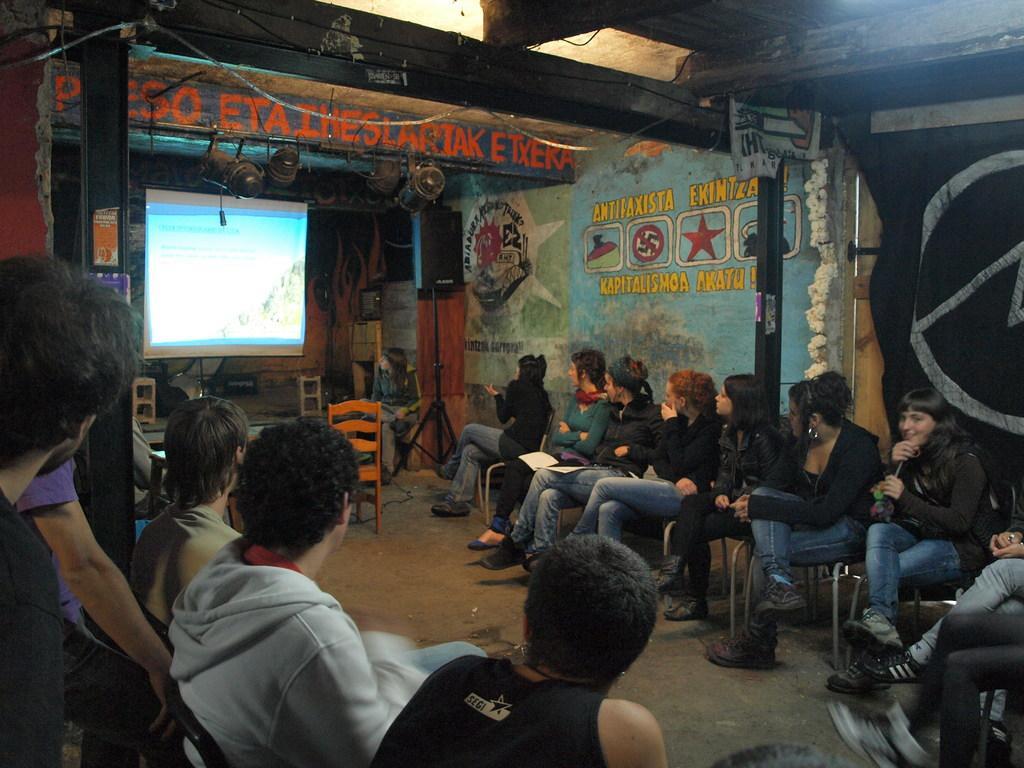In one or two sentences, can you explain what this image depicts? Here we can see a group of people sitting on chairs and opposite to them there is a projector screen they are watching something on it and beside that there is speaker present 